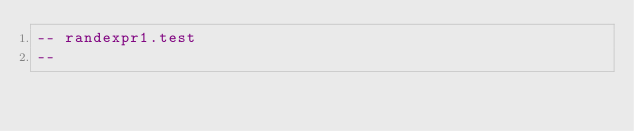<code> <loc_0><loc_0><loc_500><loc_500><_SQL_>-- randexpr1.test
-- </code> 